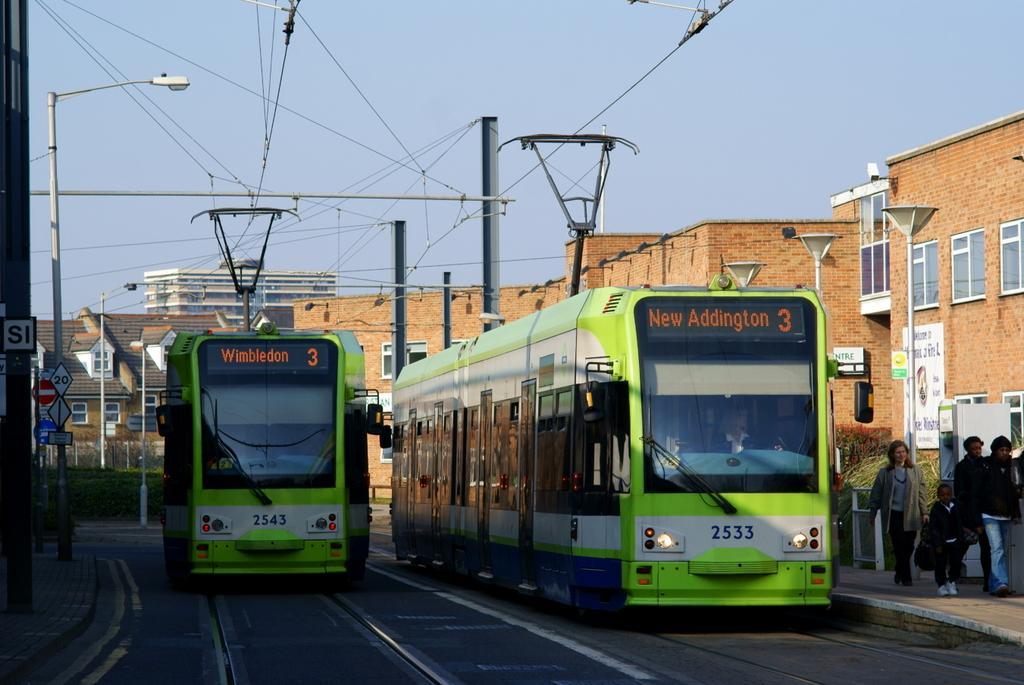Can you describe this image briefly? In the center of the image we can see two buses on the road. And we can see one person in one of the buses. In the background, we can see the sky, buildings, poles, wires, windows, plants, sign boards, few people are walking and a few other objects. 